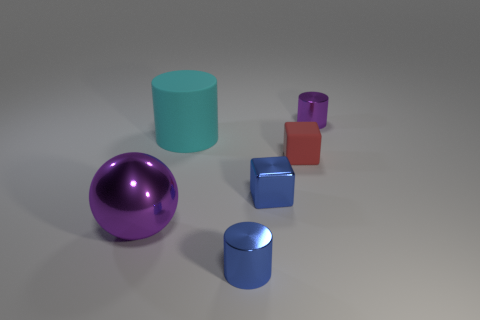How many metallic objects are the same size as the red rubber thing?
Provide a short and direct response. 3. There is a small metallic cylinder to the right of the shiny cylinder that is in front of the small purple cylinder; what color is it?
Your answer should be very brief. Purple. Are any red rubber things visible?
Make the answer very short. Yes. Is the shape of the big purple metal thing the same as the red rubber object?
Your answer should be very brief. No. There is a metal cylinder that is the same color as the large ball; what size is it?
Offer a terse response. Small. There is a small shiny cylinder behind the big purple thing; how many tiny blue things are behind it?
Keep it short and to the point. 0. What number of things are right of the cyan thing and in front of the big cyan object?
Provide a succinct answer. 3. What number of objects are small brown cylinders or small cylinders that are on the left side of the small rubber thing?
Your answer should be compact. 1. What is the size of the red block that is the same material as the big cylinder?
Your response must be concise. Small. What is the shape of the large thing that is to the right of the big object that is in front of the large matte cylinder?
Give a very brief answer. Cylinder. 